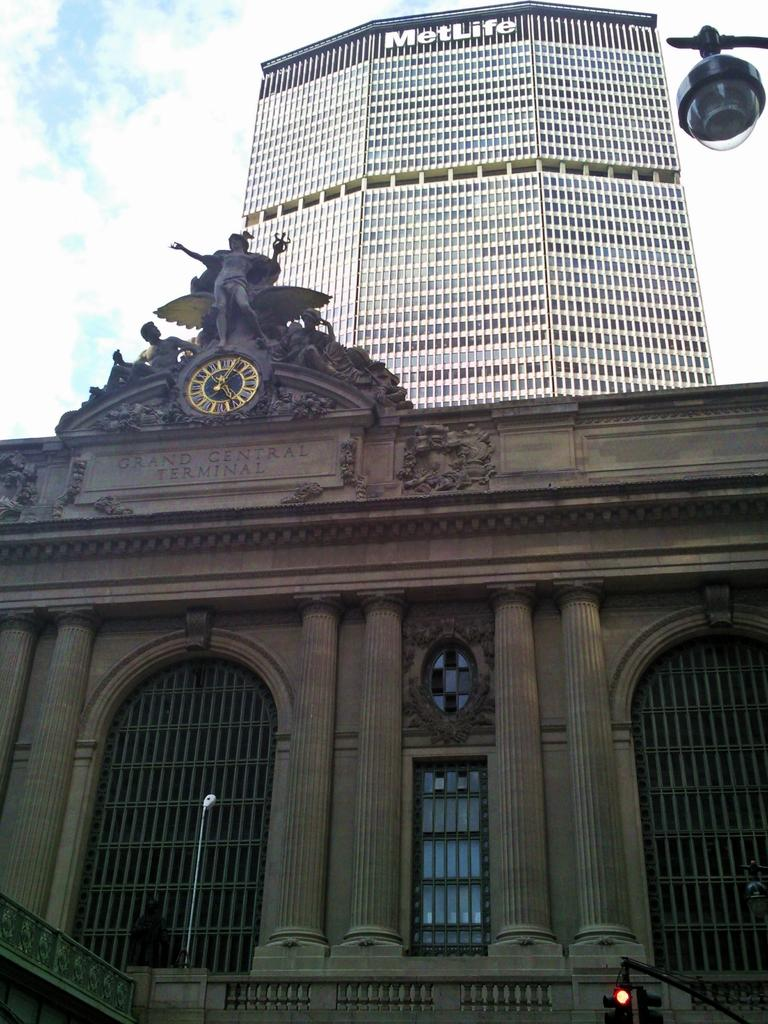<image>
Give a short and clear explanation of the subsequent image. The Grand Central Terminal has a backdrop of the Met Life Building. 